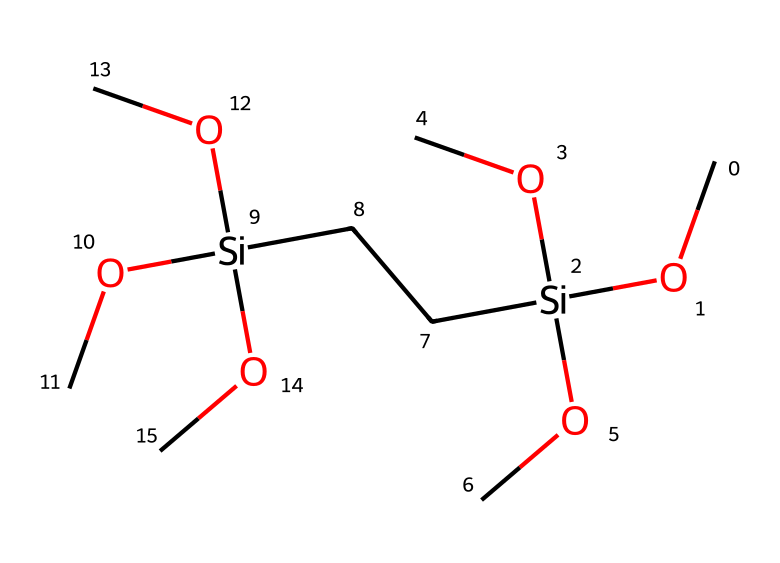What is the molecular formula of 1,2-bis(trimethoxysilyl)ethane? The SMILES representation indicates there are two silicon (Si) atoms and contains 12 oxygen (O) atoms from the methoxy groups. Counting the carbon (C) atoms from the ethane backbone and methoxy groups, the total formula can be derived and is C8H18O6Si2.
Answer: C8H18O6Si2 How many silicon atoms are present in the molecule? By examining the SMILES representation (CO[Si](OC)(OC)CC[Si](OC)(OC)OC), it's clear that there are two occurrences of '[Si]', representing two silicon atoms.
Answer: 2 What type of bonding is primarily present in 1,2-bis(trimethoxysilyl)ethane? The structure contains multiple silicon-oxygen (Si-O) ester linkages from the methoxy groups, which indicates the presence of covalent bonding. Additionally, the carbon backbone shows carbon-carbon (C-C) covalent bonds.
Answer: covalent What functional groups are present in this compound? The SMILES shows multiple 'OC' fragments which represent methoxy groups (-OCH3), indicating the presence of ether functional groups as well as the alkane chain which indicates a hydrocarbon (alkyl) component.
Answer: methoxy groups How does the presence of multiple methoxy groups affect the properties of the silane? The methoxy groups enhance the chemical reactivity and hydrophilicity of the silane, making it effective in forming adhesion to various surfaces in adhesives and coatings.
Answer: increased reactivity Which silane feature influences its use in adhesives and coatings? The presence of two trimethoxy groups allows the molecule to bond with both inorganic substrates (through the silicon) and organic components (through the methoxy groups), leading to improved adhesion.
Answer: trimethoxy groups What is the role of the ethane backbone in the structure? The ethane backbone functions as a spacer between the two silicon centers, providing structural integrity while allowing for flexibility in how the molecule interacts with surfaces in applications as an adhesive.
Answer: spacer 